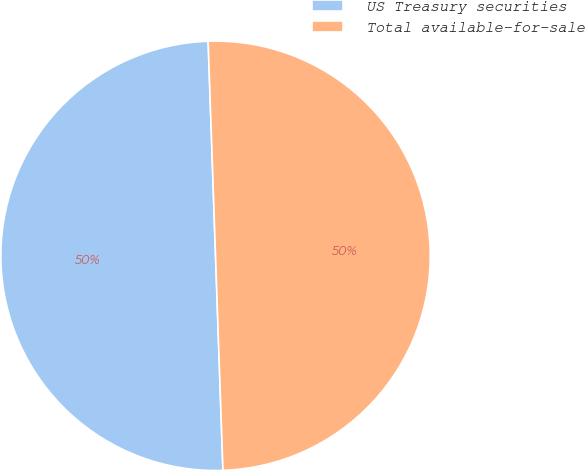Convert chart. <chart><loc_0><loc_0><loc_500><loc_500><pie_chart><fcel>US Treasury securities<fcel>Total available-for-sale<nl><fcel>50.0%<fcel>50.0%<nl></chart> 